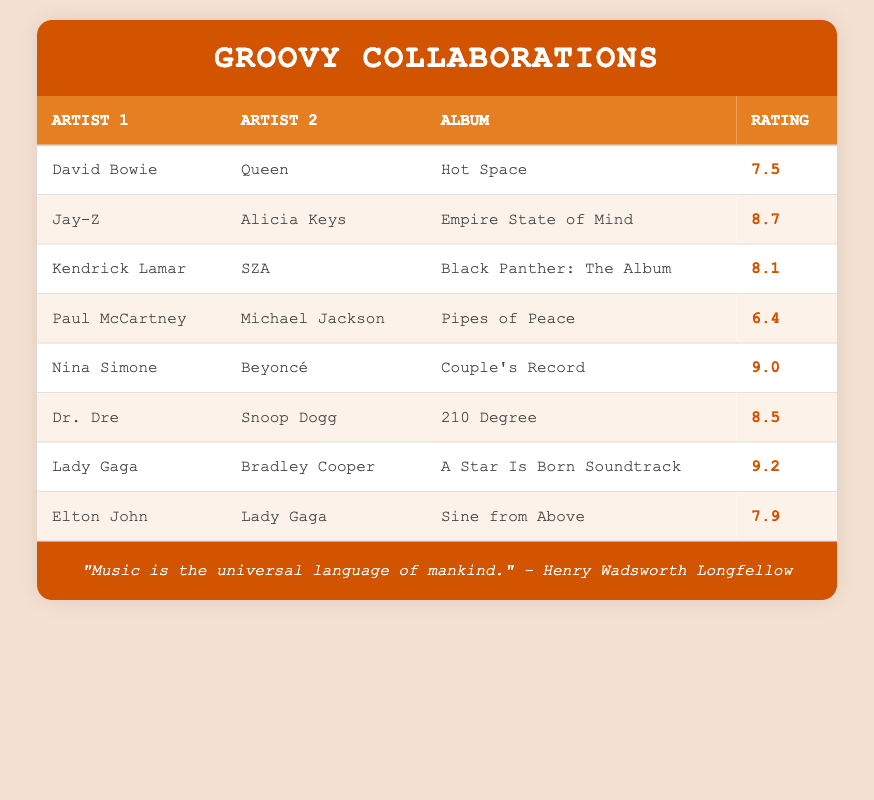What is the highest album rating in the table? The album "A Star Is Born Soundtrack" by Lady Gaga and Bradley Cooper has the highest rating of 9.2, when checking all the ratings listed.
Answer: 9.2 Which collaboration features the album "Empire State of Mind"? The album "Empire State of Mind" is a collaboration between Jay-Z and Alicia Keys, as indicated in the table.
Answer: Jay-Z and Alicia Keys What is the average rating of the albums listed? The ratings are 7.5, 8.7, 8.1, 6.4, 9.0, 8.5, 9.2, and 7.9. Summing these ratings gives a total of 66.9. There are 8 albums, so the average rating is 66.9 / 8 = 8.3625, which rounds to approximately 8.4.
Answer: 8.4 Did Paul McCartney and Michael Jackson have a higher album rating than Dr. Dre and Snoop Dogg? Paul McCartney and Michael Jackson's "Pipes of Peace" has a rating of 6.4, while Dr. Dre and Snoop Dogg's "210 Degree" has a rating of 8.5. 6.4 is not higher than 8.5.
Answer: No Which two artists collaborated for the album with a rating of 9.0? The album with a rating of 9.0 is "Couple's Record," and it features Nina Simone and Beyoncé as collaborators, according to the table.
Answer: Nina Simone and Beyoncé What is the difference between the highest and lowest album ratings? The highest album rating is 9.2 (from "A Star Is Born Soundtrack") and the lowest is 6.4 (from "Pipes of Peace"). The difference is 9.2 - 6.4 = 2.8.
Answer: 2.8 How many collaborations have a rating of 8 or higher? The albums that have ratings of 8 or higher are: "Empire State of Mind" (8.7), "Black Panther: The Album" (8.1), "210 Degree" (8.5), "Couple's Record" (9.0), "A Star Is Born Soundtrack" (9.2), and "Sine from Above" (7.9). There are 5 albums with a rating of 8 or higher.
Answer: 5 Is there an album rated 9 or above, and who are the artists? Yes, "Couple's Record" by Nina Simone and Beyoncé has a rating of 9.0, and "A Star Is Born Soundtrack" by Lady Gaga and Bradley Cooper has a rating of 9.2, both rated 9 or above.
Answer: Yes, Nina Simone and Beyoncé; Lady Gaga and Bradley Cooper 